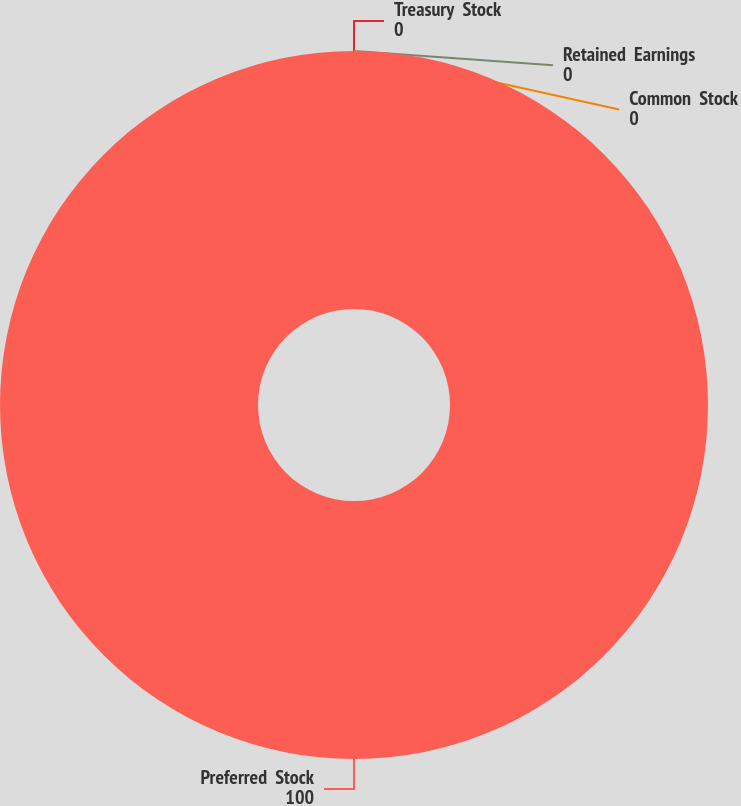Convert chart to OTSL. <chart><loc_0><loc_0><loc_500><loc_500><pie_chart><fcel>Preferred  Stock<fcel>Treasury  Stock<fcel>Retained  Earnings<fcel>Common  Stock<nl><fcel>100.0%<fcel>0.0%<fcel>0.0%<fcel>0.0%<nl></chart> 